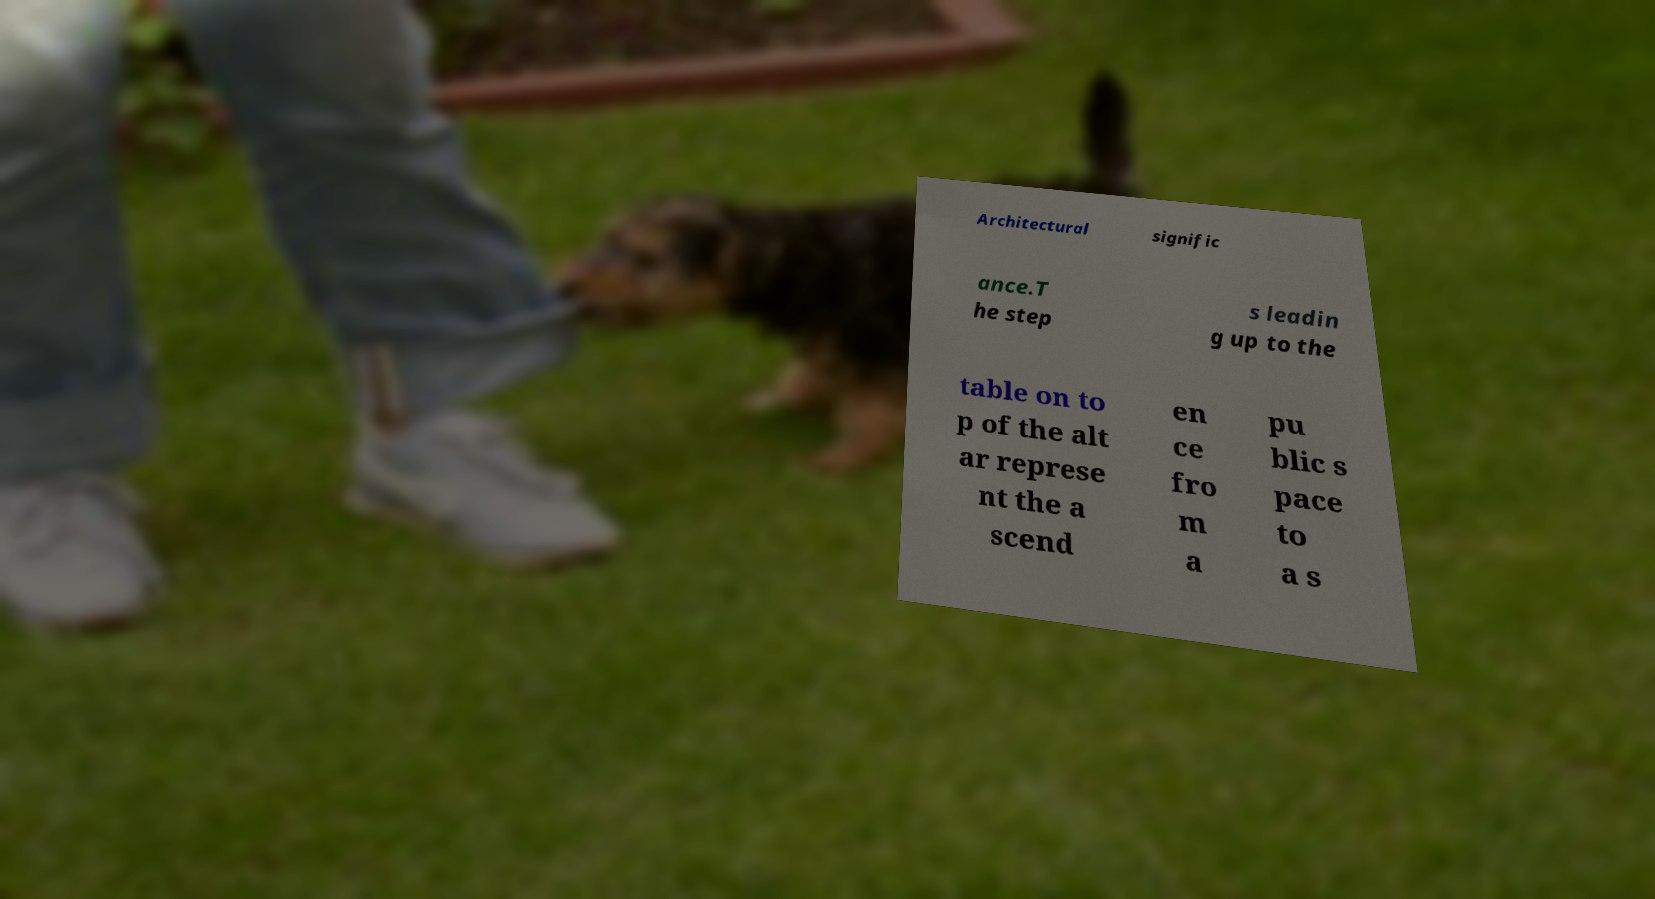Please identify and transcribe the text found in this image. Architectural signific ance.T he step s leadin g up to the table on to p of the alt ar represe nt the a scend en ce fro m a pu blic s pace to a s 